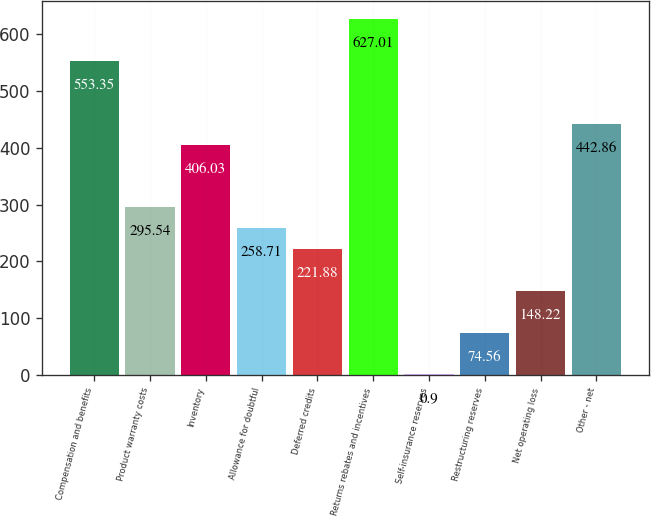<chart> <loc_0><loc_0><loc_500><loc_500><bar_chart><fcel>Compensation and benefits<fcel>Product warranty costs<fcel>Inventory<fcel>Allowance for doubtful<fcel>Deferred credits<fcel>Returns rebates and incentives<fcel>Self-insurance reserves<fcel>Restructuring reserves<fcel>Net operating loss<fcel>Other - net<nl><fcel>553.35<fcel>295.54<fcel>406.03<fcel>258.71<fcel>221.88<fcel>627.01<fcel>0.9<fcel>74.56<fcel>148.22<fcel>442.86<nl></chart> 